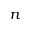Convert formula to latex. <formula><loc_0><loc_0><loc_500><loc_500>n</formula> 